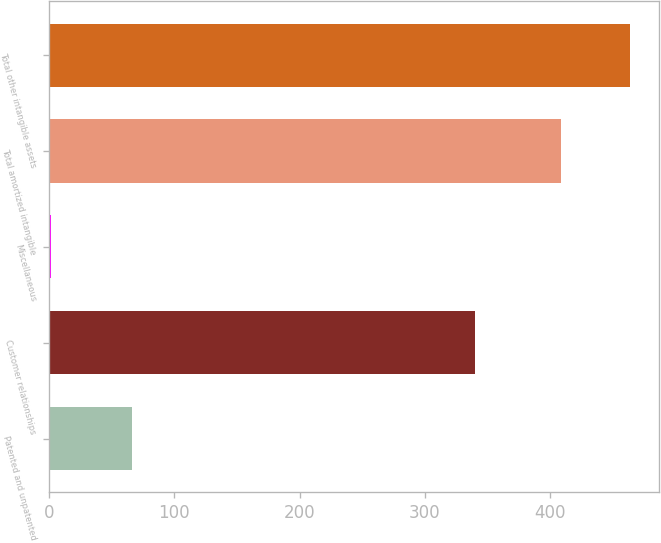Convert chart. <chart><loc_0><loc_0><loc_500><loc_500><bar_chart><fcel>Patented and unpatented<fcel>Customer relationships<fcel>Miscellaneous<fcel>Total amortized intangible<fcel>Total other intangible assets<nl><fcel>66.6<fcel>340.2<fcel>1.9<fcel>408.7<fcel>463.5<nl></chart> 